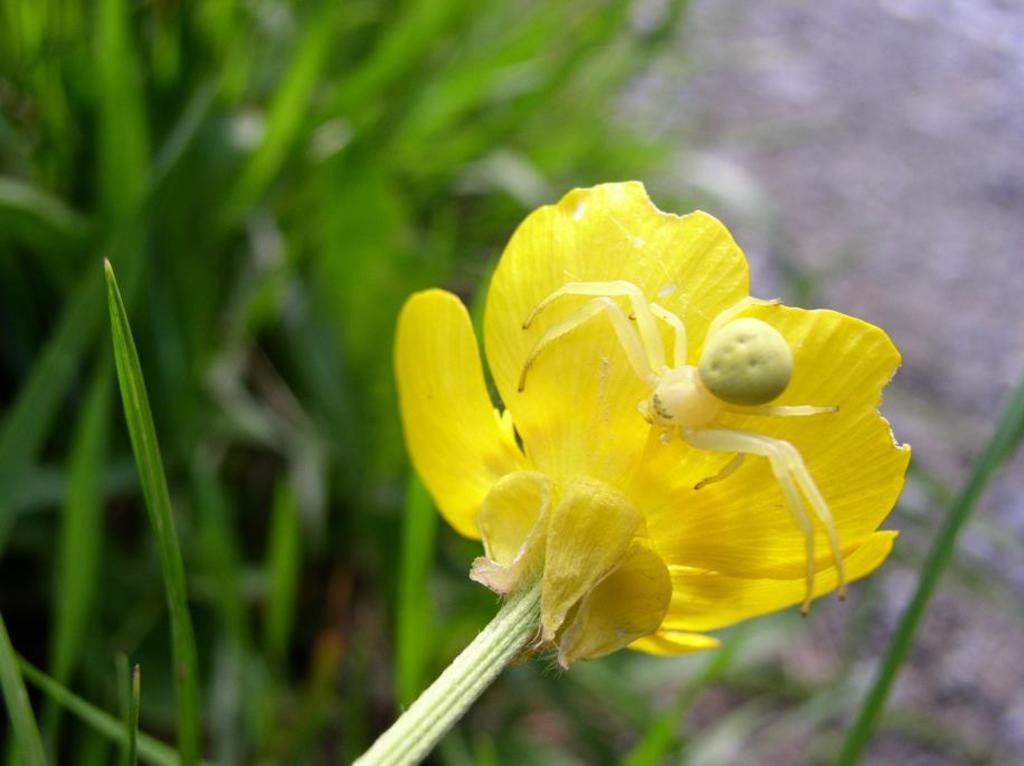What is on the flower in the image? There is an insect on a flower in the image. What color are the petals of the flower? The flower has yellow petals. What can be seen in the background of the image? There are leaves visible in the background of the image. How many bags are being carried by the group of people in the image? There is no group of people or bags present in the image; it features an insect on a flower with yellow petals and leaves in the background. 